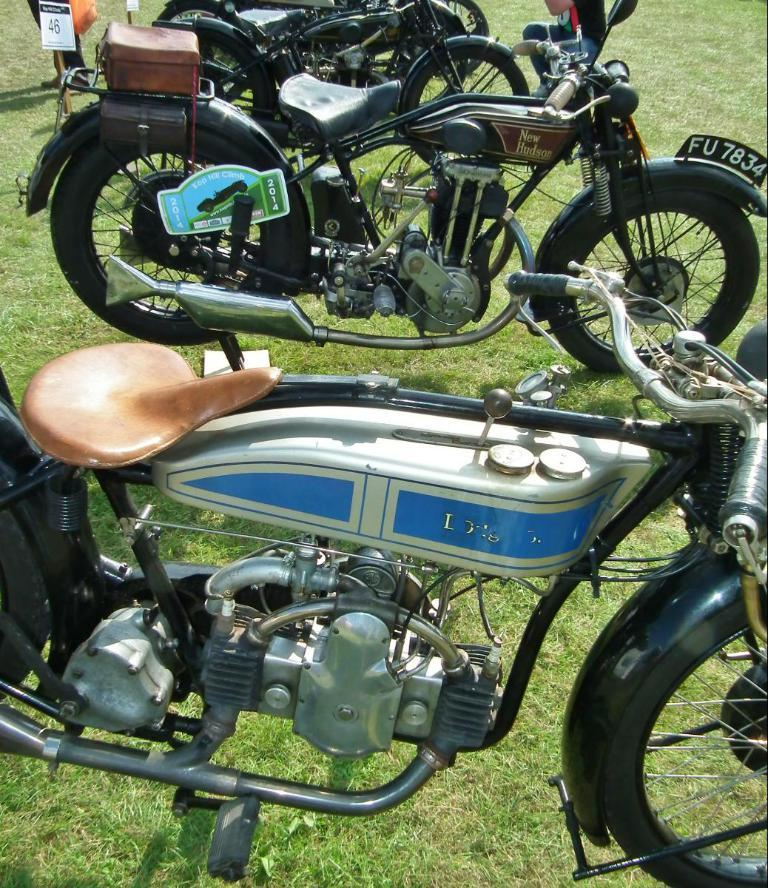What type of vehicles are present in the image? There are bikes in the image. What can be seen on the left side of the image? There are boards on the left side of the image. What type of vegetation is visible at the bottom portion of the image? There is green grass visible at the bottom portion of the image. What unit of measurement is used to describe the writer's daughter in the image? There is no writer or daughter present in the image, so it is not possible to answer that question. 